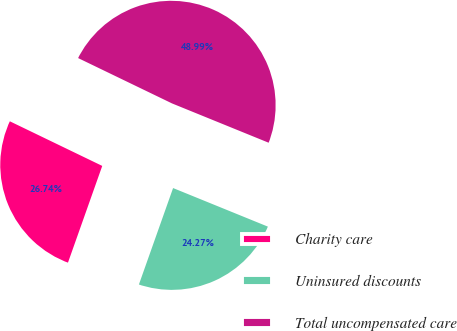Convert chart to OTSL. <chart><loc_0><loc_0><loc_500><loc_500><pie_chart><fcel>Charity care<fcel>Uninsured discounts<fcel>Total uncompensated care<nl><fcel>26.74%<fcel>24.27%<fcel>48.99%<nl></chart> 